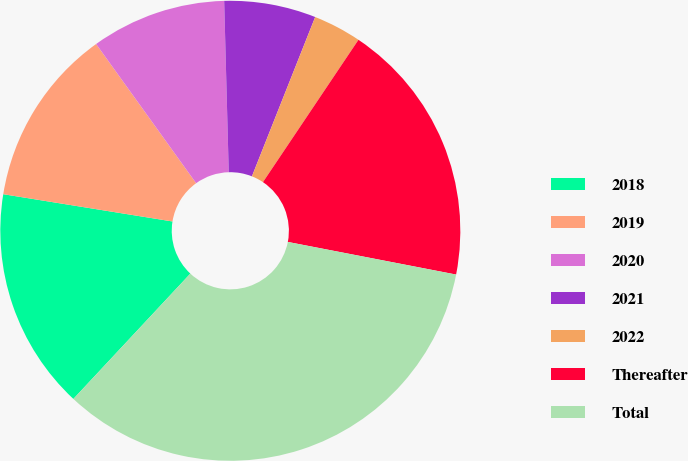<chart> <loc_0><loc_0><loc_500><loc_500><pie_chart><fcel>2018<fcel>2019<fcel>2020<fcel>2021<fcel>2022<fcel>Thereafter<fcel>Total<nl><fcel>15.59%<fcel>12.54%<fcel>9.49%<fcel>6.44%<fcel>3.39%<fcel>18.64%<fcel>33.9%<nl></chart> 